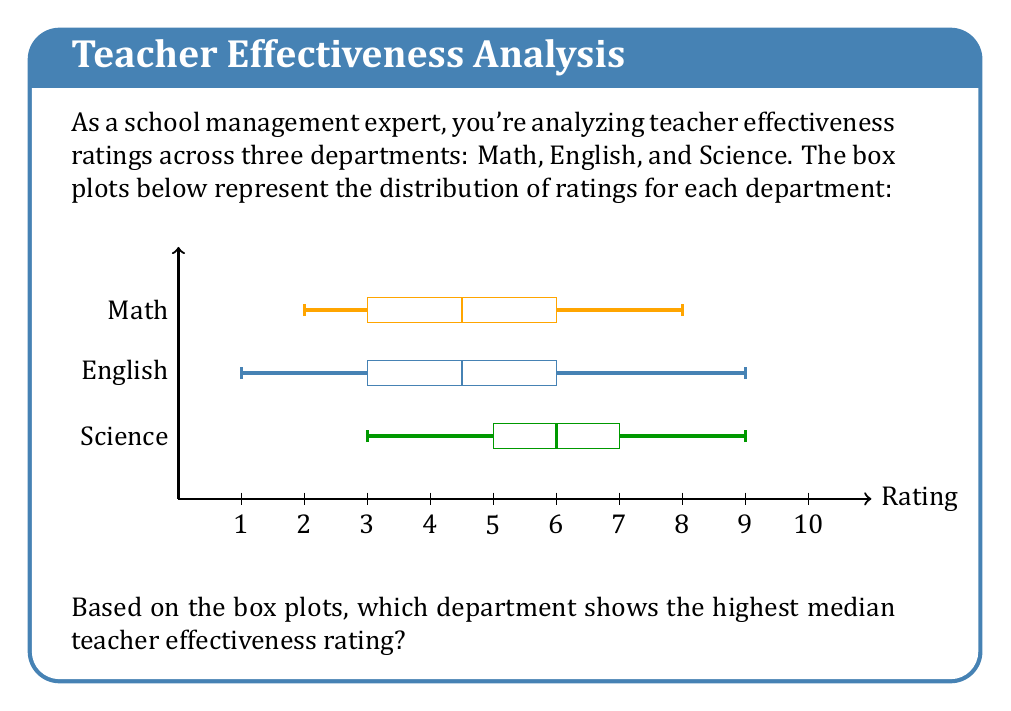Provide a solution to this math problem. To determine which department has the highest median teacher effectiveness rating, we need to compare the median (represented by the vertical line inside each box) for each department:

1. Math department: The median is approximately 5.
2. English department: The median is approximately 4.5.
3. Science department: The median is approximately 6.

The median represents the middle value in a dataset, with 50% of the data points falling below it and 50% above it. In a box plot, the median is represented by the vertical line inside the box.

Comparing these values:

$$ 6 > 5 > 4.5 $$

We can see that the Science department has the highest median at approximately 6.
Answer: Science department 